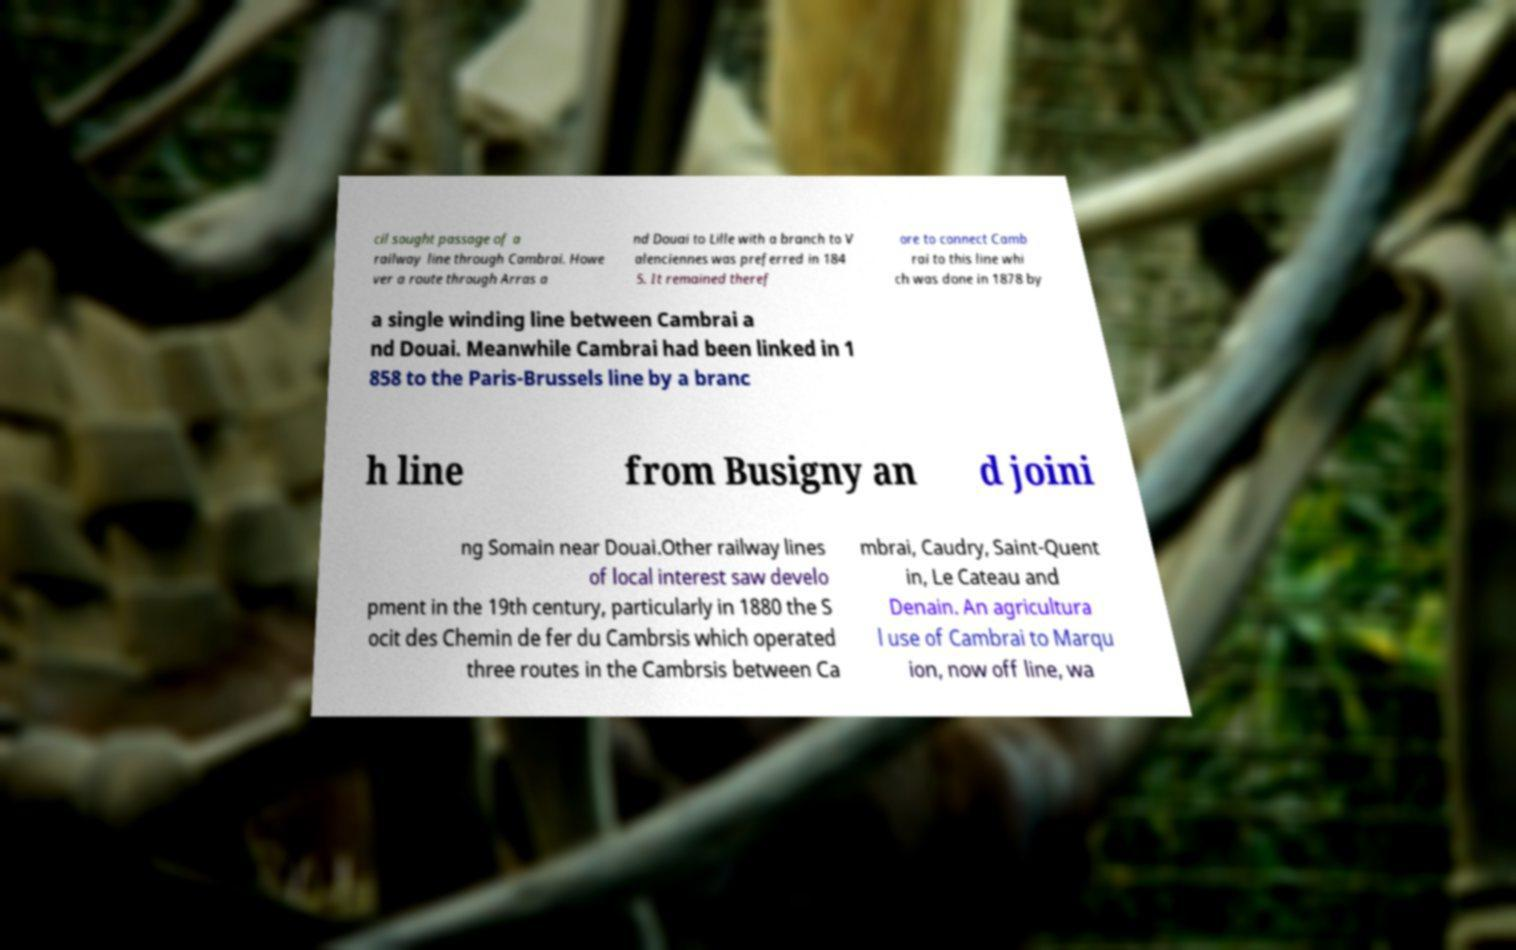Can you read and provide the text displayed in the image?This photo seems to have some interesting text. Can you extract and type it out for me? cil sought passage of a railway line through Cambrai. Howe ver a route through Arras a nd Douai to Lille with a branch to V alenciennes was preferred in 184 5. It remained theref ore to connect Camb rai to this line whi ch was done in 1878 by a single winding line between Cambrai a nd Douai. Meanwhile Cambrai had been linked in 1 858 to the Paris-Brussels line by a branc h line from Busigny an d joini ng Somain near Douai.Other railway lines of local interest saw develo pment in the 19th century, particularly in 1880 the S ocit des Chemin de fer du Cambrsis which operated three routes in the Cambrsis between Ca mbrai, Caudry, Saint-Quent in, Le Cateau and Denain. An agricultura l use of Cambrai to Marqu ion, now off line, wa 